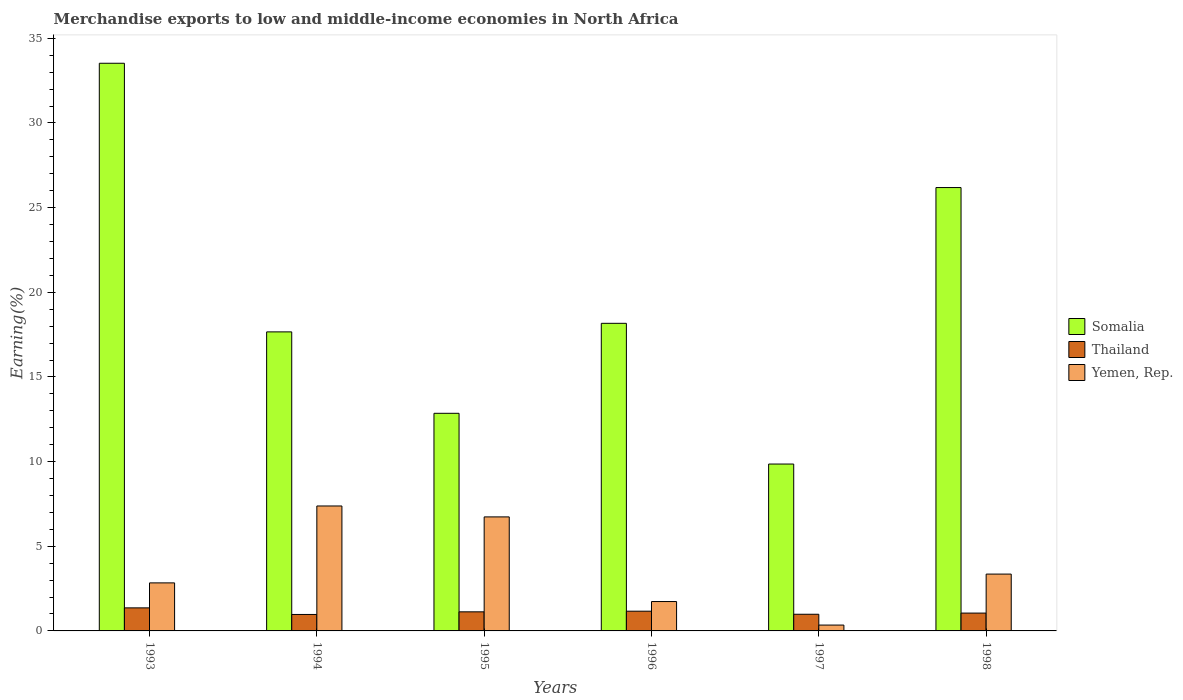How many groups of bars are there?
Provide a succinct answer. 6. Are the number of bars per tick equal to the number of legend labels?
Give a very brief answer. Yes. Are the number of bars on each tick of the X-axis equal?
Your answer should be compact. Yes. How many bars are there on the 1st tick from the left?
Make the answer very short. 3. How many bars are there on the 3rd tick from the right?
Provide a succinct answer. 3. What is the percentage of amount earned from merchandise exports in Yemen, Rep. in 1993?
Offer a very short reply. 2.84. Across all years, what is the maximum percentage of amount earned from merchandise exports in Thailand?
Make the answer very short. 1.36. Across all years, what is the minimum percentage of amount earned from merchandise exports in Thailand?
Make the answer very short. 0.97. What is the total percentage of amount earned from merchandise exports in Thailand in the graph?
Provide a short and direct response. 6.66. What is the difference between the percentage of amount earned from merchandise exports in Thailand in 1995 and that in 1997?
Provide a succinct answer. 0.14. What is the difference between the percentage of amount earned from merchandise exports in Yemen, Rep. in 1997 and the percentage of amount earned from merchandise exports in Somalia in 1994?
Keep it short and to the point. -17.32. What is the average percentage of amount earned from merchandise exports in Yemen, Rep. per year?
Offer a terse response. 3.73. In the year 1995, what is the difference between the percentage of amount earned from merchandise exports in Thailand and percentage of amount earned from merchandise exports in Somalia?
Give a very brief answer. -11.73. In how many years, is the percentage of amount earned from merchandise exports in Yemen, Rep. greater than 12 %?
Ensure brevity in your answer.  0. What is the ratio of the percentage of amount earned from merchandise exports in Thailand in 1994 to that in 1995?
Keep it short and to the point. 0.86. Is the difference between the percentage of amount earned from merchandise exports in Thailand in 1994 and 1997 greater than the difference between the percentage of amount earned from merchandise exports in Somalia in 1994 and 1997?
Your answer should be compact. No. What is the difference between the highest and the second highest percentage of amount earned from merchandise exports in Yemen, Rep.?
Provide a short and direct response. 0.65. What is the difference between the highest and the lowest percentage of amount earned from merchandise exports in Thailand?
Offer a terse response. 0.39. In how many years, is the percentage of amount earned from merchandise exports in Somalia greater than the average percentage of amount earned from merchandise exports in Somalia taken over all years?
Your response must be concise. 2. What does the 3rd bar from the left in 1994 represents?
Your answer should be very brief. Yemen, Rep. What does the 3rd bar from the right in 1995 represents?
Provide a short and direct response. Somalia. Is it the case that in every year, the sum of the percentage of amount earned from merchandise exports in Thailand and percentage of amount earned from merchandise exports in Yemen, Rep. is greater than the percentage of amount earned from merchandise exports in Somalia?
Your answer should be compact. No. Are all the bars in the graph horizontal?
Your answer should be compact. No. How many years are there in the graph?
Offer a terse response. 6. What is the difference between two consecutive major ticks on the Y-axis?
Provide a short and direct response. 5. Does the graph contain any zero values?
Provide a succinct answer. No. Does the graph contain grids?
Make the answer very short. No. Where does the legend appear in the graph?
Offer a very short reply. Center right. How are the legend labels stacked?
Keep it short and to the point. Vertical. What is the title of the graph?
Provide a short and direct response. Merchandise exports to low and middle-income economies in North Africa. Does "New Caledonia" appear as one of the legend labels in the graph?
Your response must be concise. No. What is the label or title of the X-axis?
Provide a succinct answer. Years. What is the label or title of the Y-axis?
Offer a terse response. Earning(%). What is the Earning(%) of Somalia in 1993?
Keep it short and to the point. 33.53. What is the Earning(%) of Thailand in 1993?
Your answer should be compact. 1.36. What is the Earning(%) in Yemen, Rep. in 1993?
Ensure brevity in your answer.  2.84. What is the Earning(%) in Somalia in 1994?
Offer a very short reply. 17.66. What is the Earning(%) of Thailand in 1994?
Offer a terse response. 0.97. What is the Earning(%) in Yemen, Rep. in 1994?
Provide a succinct answer. 7.38. What is the Earning(%) in Somalia in 1995?
Your answer should be compact. 12.85. What is the Earning(%) in Thailand in 1995?
Keep it short and to the point. 1.13. What is the Earning(%) in Yemen, Rep. in 1995?
Make the answer very short. 6.73. What is the Earning(%) of Somalia in 1996?
Offer a very short reply. 18.17. What is the Earning(%) in Thailand in 1996?
Provide a short and direct response. 1.17. What is the Earning(%) of Yemen, Rep. in 1996?
Offer a very short reply. 1.74. What is the Earning(%) in Somalia in 1997?
Keep it short and to the point. 9.86. What is the Earning(%) of Thailand in 1997?
Offer a terse response. 0.98. What is the Earning(%) of Yemen, Rep. in 1997?
Your answer should be very brief. 0.35. What is the Earning(%) of Somalia in 1998?
Your response must be concise. 26.19. What is the Earning(%) of Thailand in 1998?
Make the answer very short. 1.05. What is the Earning(%) in Yemen, Rep. in 1998?
Keep it short and to the point. 3.36. Across all years, what is the maximum Earning(%) of Somalia?
Your answer should be very brief. 33.53. Across all years, what is the maximum Earning(%) of Thailand?
Provide a succinct answer. 1.36. Across all years, what is the maximum Earning(%) in Yemen, Rep.?
Ensure brevity in your answer.  7.38. Across all years, what is the minimum Earning(%) of Somalia?
Give a very brief answer. 9.86. Across all years, what is the minimum Earning(%) of Thailand?
Offer a terse response. 0.97. Across all years, what is the minimum Earning(%) of Yemen, Rep.?
Provide a succinct answer. 0.35. What is the total Earning(%) in Somalia in the graph?
Ensure brevity in your answer.  118.26. What is the total Earning(%) of Thailand in the graph?
Make the answer very short. 6.66. What is the total Earning(%) of Yemen, Rep. in the graph?
Give a very brief answer. 22.39. What is the difference between the Earning(%) in Somalia in 1993 and that in 1994?
Your answer should be compact. 15.87. What is the difference between the Earning(%) of Thailand in 1993 and that in 1994?
Your response must be concise. 0.39. What is the difference between the Earning(%) of Yemen, Rep. in 1993 and that in 1994?
Your answer should be compact. -4.54. What is the difference between the Earning(%) of Somalia in 1993 and that in 1995?
Keep it short and to the point. 20.67. What is the difference between the Earning(%) of Thailand in 1993 and that in 1995?
Offer a terse response. 0.23. What is the difference between the Earning(%) of Yemen, Rep. in 1993 and that in 1995?
Your answer should be compact. -3.9. What is the difference between the Earning(%) in Somalia in 1993 and that in 1996?
Make the answer very short. 15.36. What is the difference between the Earning(%) of Thailand in 1993 and that in 1996?
Your answer should be very brief. 0.2. What is the difference between the Earning(%) of Yemen, Rep. in 1993 and that in 1996?
Provide a short and direct response. 1.1. What is the difference between the Earning(%) of Somalia in 1993 and that in 1997?
Provide a succinct answer. 23.67. What is the difference between the Earning(%) in Thailand in 1993 and that in 1997?
Your answer should be very brief. 0.38. What is the difference between the Earning(%) of Yemen, Rep. in 1993 and that in 1997?
Offer a terse response. 2.49. What is the difference between the Earning(%) in Somalia in 1993 and that in 1998?
Provide a succinct answer. 7.34. What is the difference between the Earning(%) in Thailand in 1993 and that in 1998?
Your answer should be compact. 0.31. What is the difference between the Earning(%) of Yemen, Rep. in 1993 and that in 1998?
Your answer should be compact. -0.52. What is the difference between the Earning(%) of Somalia in 1994 and that in 1995?
Provide a succinct answer. 4.81. What is the difference between the Earning(%) of Thailand in 1994 and that in 1995?
Give a very brief answer. -0.16. What is the difference between the Earning(%) in Yemen, Rep. in 1994 and that in 1995?
Provide a succinct answer. 0.65. What is the difference between the Earning(%) in Somalia in 1994 and that in 1996?
Keep it short and to the point. -0.51. What is the difference between the Earning(%) in Thailand in 1994 and that in 1996?
Your answer should be very brief. -0.19. What is the difference between the Earning(%) in Yemen, Rep. in 1994 and that in 1996?
Make the answer very short. 5.64. What is the difference between the Earning(%) of Somalia in 1994 and that in 1997?
Your answer should be compact. 7.81. What is the difference between the Earning(%) of Thailand in 1994 and that in 1997?
Offer a terse response. -0.01. What is the difference between the Earning(%) in Yemen, Rep. in 1994 and that in 1997?
Your answer should be compact. 7.03. What is the difference between the Earning(%) in Somalia in 1994 and that in 1998?
Give a very brief answer. -8.52. What is the difference between the Earning(%) of Thailand in 1994 and that in 1998?
Offer a terse response. -0.08. What is the difference between the Earning(%) in Yemen, Rep. in 1994 and that in 1998?
Your answer should be very brief. 4.02. What is the difference between the Earning(%) in Somalia in 1995 and that in 1996?
Your response must be concise. -5.31. What is the difference between the Earning(%) of Thailand in 1995 and that in 1996?
Offer a terse response. -0.04. What is the difference between the Earning(%) of Yemen, Rep. in 1995 and that in 1996?
Make the answer very short. 5. What is the difference between the Earning(%) of Somalia in 1995 and that in 1997?
Make the answer very short. 3. What is the difference between the Earning(%) in Thailand in 1995 and that in 1997?
Keep it short and to the point. 0.14. What is the difference between the Earning(%) in Yemen, Rep. in 1995 and that in 1997?
Offer a very short reply. 6.39. What is the difference between the Earning(%) in Somalia in 1995 and that in 1998?
Give a very brief answer. -13.33. What is the difference between the Earning(%) of Thailand in 1995 and that in 1998?
Make the answer very short. 0.07. What is the difference between the Earning(%) in Yemen, Rep. in 1995 and that in 1998?
Keep it short and to the point. 3.38. What is the difference between the Earning(%) of Somalia in 1996 and that in 1997?
Offer a very short reply. 8.31. What is the difference between the Earning(%) in Thailand in 1996 and that in 1997?
Provide a short and direct response. 0.18. What is the difference between the Earning(%) of Yemen, Rep. in 1996 and that in 1997?
Offer a terse response. 1.39. What is the difference between the Earning(%) of Somalia in 1996 and that in 1998?
Make the answer very short. -8.02. What is the difference between the Earning(%) of Thailand in 1996 and that in 1998?
Offer a very short reply. 0.11. What is the difference between the Earning(%) of Yemen, Rep. in 1996 and that in 1998?
Provide a succinct answer. -1.62. What is the difference between the Earning(%) of Somalia in 1997 and that in 1998?
Your response must be concise. -16.33. What is the difference between the Earning(%) in Thailand in 1997 and that in 1998?
Make the answer very short. -0.07. What is the difference between the Earning(%) in Yemen, Rep. in 1997 and that in 1998?
Your answer should be compact. -3.01. What is the difference between the Earning(%) of Somalia in 1993 and the Earning(%) of Thailand in 1994?
Provide a short and direct response. 32.56. What is the difference between the Earning(%) of Somalia in 1993 and the Earning(%) of Yemen, Rep. in 1994?
Your answer should be compact. 26.15. What is the difference between the Earning(%) of Thailand in 1993 and the Earning(%) of Yemen, Rep. in 1994?
Give a very brief answer. -6.02. What is the difference between the Earning(%) in Somalia in 1993 and the Earning(%) in Thailand in 1995?
Your response must be concise. 32.4. What is the difference between the Earning(%) of Somalia in 1993 and the Earning(%) of Yemen, Rep. in 1995?
Your answer should be very brief. 26.79. What is the difference between the Earning(%) of Thailand in 1993 and the Earning(%) of Yemen, Rep. in 1995?
Your answer should be very brief. -5.37. What is the difference between the Earning(%) in Somalia in 1993 and the Earning(%) in Thailand in 1996?
Provide a short and direct response. 32.36. What is the difference between the Earning(%) in Somalia in 1993 and the Earning(%) in Yemen, Rep. in 1996?
Provide a succinct answer. 31.79. What is the difference between the Earning(%) in Thailand in 1993 and the Earning(%) in Yemen, Rep. in 1996?
Your answer should be very brief. -0.37. What is the difference between the Earning(%) in Somalia in 1993 and the Earning(%) in Thailand in 1997?
Your answer should be very brief. 32.54. What is the difference between the Earning(%) in Somalia in 1993 and the Earning(%) in Yemen, Rep. in 1997?
Keep it short and to the point. 33.18. What is the difference between the Earning(%) of Thailand in 1993 and the Earning(%) of Yemen, Rep. in 1997?
Your answer should be compact. 1.02. What is the difference between the Earning(%) in Somalia in 1993 and the Earning(%) in Thailand in 1998?
Provide a succinct answer. 32.47. What is the difference between the Earning(%) of Somalia in 1993 and the Earning(%) of Yemen, Rep. in 1998?
Offer a very short reply. 30.17. What is the difference between the Earning(%) of Thailand in 1993 and the Earning(%) of Yemen, Rep. in 1998?
Your answer should be very brief. -2. What is the difference between the Earning(%) in Somalia in 1994 and the Earning(%) in Thailand in 1995?
Ensure brevity in your answer.  16.53. What is the difference between the Earning(%) in Somalia in 1994 and the Earning(%) in Yemen, Rep. in 1995?
Offer a terse response. 10.93. What is the difference between the Earning(%) of Thailand in 1994 and the Earning(%) of Yemen, Rep. in 1995?
Give a very brief answer. -5.76. What is the difference between the Earning(%) in Somalia in 1994 and the Earning(%) in Thailand in 1996?
Your answer should be compact. 16.5. What is the difference between the Earning(%) in Somalia in 1994 and the Earning(%) in Yemen, Rep. in 1996?
Provide a short and direct response. 15.93. What is the difference between the Earning(%) of Thailand in 1994 and the Earning(%) of Yemen, Rep. in 1996?
Ensure brevity in your answer.  -0.76. What is the difference between the Earning(%) in Somalia in 1994 and the Earning(%) in Thailand in 1997?
Your response must be concise. 16.68. What is the difference between the Earning(%) in Somalia in 1994 and the Earning(%) in Yemen, Rep. in 1997?
Provide a short and direct response. 17.32. What is the difference between the Earning(%) in Thailand in 1994 and the Earning(%) in Yemen, Rep. in 1997?
Your answer should be very brief. 0.63. What is the difference between the Earning(%) in Somalia in 1994 and the Earning(%) in Thailand in 1998?
Provide a succinct answer. 16.61. What is the difference between the Earning(%) in Somalia in 1994 and the Earning(%) in Yemen, Rep. in 1998?
Offer a terse response. 14.31. What is the difference between the Earning(%) of Thailand in 1994 and the Earning(%) of Yemen, Rep. in 1998?
Your answer should be compact. -2.39. What is the difference between the Earning(%) in Somalia in 1995 and the Earning(%) in Thailand in 1996?
Your answer should be very brief. 11.69. What is the difference between the Earning(%) of Somalia in 1995 and the Earning(%) of Yemen, Rep. in 1996?
Your answer should be compact. 11.12. What is the difference between the Earning(%) of Thailand in 1995 and the Earning(%) of Yemen, Rep. in 1996?
Your answer should be compact. -0.61. What is the difference between the Earning(%) in Somalia in 1995 and the Earning(%) in Thailand in 1997?
Offer a terse response. 11.87. What is the difference between the Earning(%) of Somalia in 1995 and the Earning(%) of Yemen, Rep. in 1997?
Offer a very short reply. 12.51. What is the difference between the Earning(%) in Thailand in 1995 and the Earning(%) in Yemen, Rep. in 1997?
Offer a terse response. 0.78. What is the difference between the Earning(%) of Somalia in 1995 and the Earning(%) of Thailand in 1998?
Your answer should be very brief. 11.8. What is the difference between the Earning(%) of Somalia in 1995 and the Earning(%) of Yemen, Rep. in 1998?
Give a very brief answer. 9.5. What is the difference between the Earning(%) of Thailand in 1995 and the Earning(%) of Yemen, Rep. in 1998?
Ensure brevity in your answer.  -2.23. What is the difference between the Earning(%) in Somalia in 1996 and the Earning(%) in Thailand in 1997?
Your answer should be compact. 17.18. What is the difference between the Earning(%) of Somalia in 1996 and the Earning(%) of Yemen, Rep. in 1997?
Your response must be concise. 17.82. What is the difference between the Earning(%) of Thailand in 1996 and the Earning(%) of Yemen, Rep. in 1997?
Your response must be concise. 0.82. What is the difference between the Earning(%) in Somalia in 1996 and the Earning(%) in Thailand in 1998?
Provide a succinct answer. 17.11. What is the difference between the Earning(%) in Somalia in 1996 and the Earning(%) in Yemen, Rep. in 1998?
Your answer should be compact. 14.81. What is the difference between the Earning(%) in Thailand in 1996 and the Earning(%) in Yemen, Rep. in 1998?
Your answer should be very brief. -2.19. What is the difference between the Earning(%) of Somalia in 1997 and the Earning(%) of Thailand in 1998?
Your answer should be compact. 8.8. What is the difference between the Earning(%) of Somalia in 1997 and the Earning(%) of Yemen, Rep. in 1998?
Your response must be concise. 6.5. What is the difference between the Earning(%) of Thailand in 1997 and the Earning(%) of Yemen, Rep. in 1998?
Your answer should be very brief. -2.37. What is the average Earning(%) in Somalia per year?
Your answer should be compact. 19.71. What is the average Earning(%) in Thailand per year?
Give a very brief answer. 1.11. What is the average Earning(%) in Yemen, Rep. per year?
Your response must be concise. 3.73. In the year 1993, what is the difference between the Earning(%) of Somalia and Earning(%) of Thailand?
Provide a succinct answer. 32.17. In the year 1993, what is the difference between the Earning(%) in Somalia and Earning(%) in Yemen, Rep.?
Ensure brevity in your answer.  30.69. In the year 1993, what is the difference between the Earning(%) of Thailand and Earning(%) of Yemen, Rep.?
Your answer should be very brief. -1.48. In the year 1994, what is the difference between the Earning(%) of Somalia and Earning(%) of Thailand?
Your answer should be very brief. 16.69. In the year 1994, what is the difference between the Earning(%) of Somalia and Earning(%) of Yemen, Rep.?
Make the answer very short. 10.28. In the year 1994, what is the difference between the Earning(%) of Thailand and Earning(%) of Yemen, Rep.?
Provide a short and direct response. -6.41. In the year 1995, what is the difference between the Earning(%) of Somalia and Earning(%) of Thailand?
Provide a short and direct response. 11.73. In the year 1995, what is the difference between the Earning(%) of Somalia and Earning(%) of Yemen, Rep.?
Your answer should be very brief. 6.12. In the year 1995, what is the difference between the Earning(%) in Thailand and Earning(%) in Yemen, Rep.?
Keep it short and to the point. -5.61. In the year 1996, what is the difference between the Earning(%) in Somalia and Earning(%) in Thailand?
Provide a short and direct response. 17. In the year 1996, what is the difference between the Earning(%) in Somalia and Earning(%) in Yemen, Rep.?
Give a very brief answer. 16.43. In the year 1996, what is the difference between the Earning(%) of Thailand and Earning(%) of Yemen, Rep.?
Provide a succinct answer. -0.57. In the year 1997, what is the difference between the Earning(%) of Somalia and Earning(%) of Thailand?
Your response must be concise. 8.87. In the year 1997, what is the difference between the Earning(%) in Somalia and Earning(%) in Yemen, Rep.?
Provide a succinct answer. 9.51. In the year 1997, what is the difference between the Earning(%) of Thailand and Earning(%) of Yemen, Rep.?
Give a very brief answer. 0.64. In the year 1998, what is the difference between the Earning(%) in Somalia and Earning(%) in Thailand?
Offer a very short reply. 25.13. In the year 1998, what is the difference between the Earning(%) of Somalia and Earning(%) of Yemen, Rep.?
Ensure brevity in your answer.  22.83. In the year 1998, what is the difference between the Earning(%) in Thailand and Earning(%) in Yemen, Rep.?
Keep it short and to the point. -2.3. What is the ratio of the Earning(%) of Somalia in 1993 to that in 1994?
Keep it short and to the point. 1.9. What is the ratio of the Earning(%) of Thailand in 1993 to that in 1994?
Give a very brief answer. 1.4. What is the ratio of the Earning(%) in Yemen, Rep. in 1993 to that in 1994?
Ensure brevity in your answer.  0.38. What is the ratio of the Earning(%) in Somalia in 1993 to that in 1995?
Your answer should be very brief. 2.61. What is the ratio of the Earning(%) in Thailand in 1993 to that in 1995?
Make the answer very short. 1.21. What is the ratio of the Earning(%) in Yemen, Rep. in 1993 to that in 1995?
Keep it short and to the point. 0.42. What is the ratio of the Earning(%) of Somalia in 1993 to that in 1996?
Your answer should be very brief. 1.85. What is the ratio of the Earning(%) in Thailand in 1993 to that in 1996?
Your answer should be compact. 1.17. What is the ratio of the Earning(%) in Yemen, Rep. in 1993 to that in 1996?
Keep it short and to the point. 1.64. What is the ratio of the Earning(%) in Somalia in 1993 to that in 1997?
Offer a very short reply. 3.4. What is the ratio of the Earning(%) of Thailand in 1993 to that in 1997?
Your answer should be very brief. 1.38. What is the ratio of the Earning(%) of Yemen, Rep. in 1993 to that in 1997?
Make the answer very short. 8.22. What is the ratio of the Earning(%) in Somalia in 1993 to that in 1998?
Ensure brevity in your answer.  1.28. What is the ratio of the Earning(%) in Thailand in 1993 to that in 1998?
Make the answer very short. 1.29. What is the ratio of the Earning(%) of Yemen, Rep. in 1993 to that in 1998?
Your response must be concise. 0.85. What is the ratio of the Earning(%) of Somalia in 1994 to that in 1995?
Your answer should be very brief. 1.37. What is the ratio of the Earning(%) in Thailand in 1994 to that in 1995?
Keep it short and to the point. 0.86. What is the ratio of the Earning(%) of Yemen, Rep. in 1994 to that in 1995?
Provide a succinct answer. 1.1. What is the ratio of the Earning(%) of Somalia in 1994 to that in 1996?
Keep it short and to the point. 0.97. What is the ratio of the Earning(%) in Thailand in 1994 to that in 1996?
Provide a succinct answer. 0.83. What is the ratio of the Earning(%) in Yemen, Rep. in 1994 to that in 1996?
Provide a succinct answer. 4.25. What is the ratio of the Earning(%) in Somalia in 1994 to that in 1997?
Provide a short and direct response. 1.79. What is the ratio of the Earning(%) in Thailand in 1994 to that in 1997?
Your answer should be compact. 0.99. What is the ratio of the Earning(%) of Yemen, Rep. in 1994 to that in 1997?
Your answer should be very brief. 21.38. What is the ratio of the Earning(%) of Somalia in 1994 to that in 1998?
Your response must be concise. 0.67. What is the ratio of the Earning(%) of Thailand in 1994 to that in 1998?
Offer a terse response. 0.92. What is the ratio of the Earning(%) in Yemen, Rep. in 1994 to that in 1998?
Provide a short and direct response. 2.2. What is the ratio of the Earning(%) in Somalia in 1995 to that in 1996?
Offer a terse response. 0.71. What is the ratio of the Earning(%) in Thailand in 1995 to that in 1996?
Provide a short and direct response. 0.97. What is the ratio of the Earning(%) of Yemen, Rep. in 1995 to that in 1996?
Provide a succinct answer. 3.88. What is the ratio of the Earning(%) of Somalia in 1995 to that in 1997?
Offer a terse response. 1.3. What is the ratio of the Earning(%) of Thailand in 1995 to that in 1997?
Keep it short and to the point. 1.15. What is the ratio of the Earning(%) of Yemen, Rep. in 1995 to that in 1997?
Your answer should be very brief. 19.51. What is the ratio of the Earning(%) in Somalia in 1995 to that in 1998?
Offer a terse response. 0.49. What is the ratio of the Earning(%) of Thailand in 1995 to that in 1998?
Make the answer very short. 1.07. What is the ratio of the Earning(%) in Yemen, Rep. in 1995 to that in 1998?
Keep it short and to the point. 2.01. What is the ratio of the Earning(%) of Somalia in 1996 to that in 1997?
Provide a succinct answer. 1.84. What is the ratio of the Earning(%) in Thailand in 1996 to that in 1997?
Your answer should be very brief. 1.18. What is the ratio of the Earning(%) in Yemen, Rep. in 1996 to that in 1997?
Keep it short and to the point. 5.03. What is the ratio of the Earning(%) in Somalia in 1996 to that in 1998?
Your answer should be very brief. 0.69. What is the ratio of the Earning(%) in Thailand in 1996 to that in 1998?
Provide a succinct answer. 1.11. What is the ratio of the Earning(%) in Yemen, Rep. in 1996 to that in 1998?
Give a very brief answer. 0.52. What is the ratio of the Earning(%) in Somalia in 1997 to that in 1998?
Offer a very short reply. 0.38. What is the ratio of the Earning(%) in Thailand in 1997 to that in 1998?
Give a very brief answer. 0.93. What is the ratio of the Earning(%) of Yemen, Rep. in 1997 to that in 1998?
Your answer should be very brief. 0.1. What is the difference between the highest and the second highest Earning(%) in Somalia?
Provide a succinct answer. 7.34. What is the difference between the highest and the second highest Earning(%) in Thailand?
Offer a terse response. 0.2. What is the difference between the highest and the second highest Earning(%) of Yemen, Rep.?
Ensure brevity in your answer.  0.65. What is the difference between the highest and the lowest Earning(%) in Somalia?
Your answer should be very brief. 23.67. What is the difference between the highest and the lowest Earning(%) of Thailand?
Provide a short and direct response. 0.39. What is the difference between the highest and the lowest Earning(%) of Yemen, Rep.?
Ensure brevity in your answer.  7.03. 